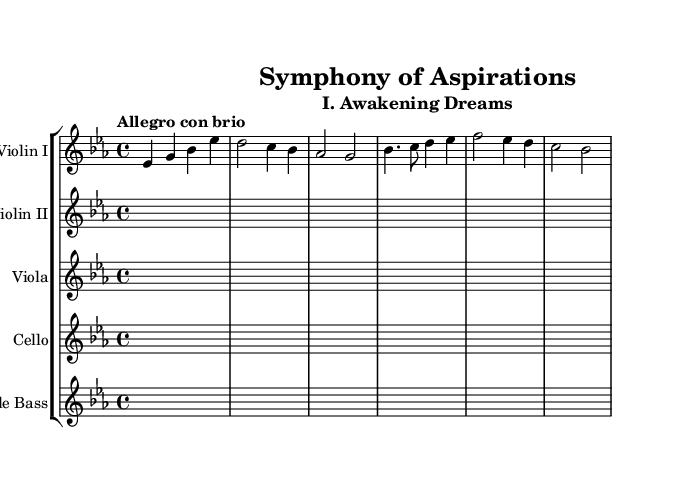What is the key signature of this music? The key signature indicates the presence of three flats, which corresponds to E flat major.
Answer: E flat major What is the time signature of this music? The time signature is found at the beginning of the staff and is represented as 4/4, indicating four beats per measure.
Answer: 4/4 What is the tempo marking for this piece? The tempo marking is written above the staff and is noted as "Allegro con brio," which describes a fast and lively pace.
Answer: Allegro con brio What is the first theme in this symphony labeled as? The first theme is labeled as "mainTheme" in the code, and its musical representation begins with the notes E flat and G.
Answer: Awakening Dreams How many different string instruments are indicated in the score? The score includes five different string instruments, as shown by the five separate staffs: Violin I, Violin II, Viola, Cello, and Double Bass.
Answer: Five What rhythmic pattern characterizes the secondary theme? The secondary theme is characterized by a dotted quarter note followed by an eighth note, which creates a syncopated feel throughout.
Answer: Dotted rhythm Which instrument has the melody in the initial section? The violin I part prominently features the melody in the initial section, as indicated by the notation placed on its staff.
Answer: Violin I 